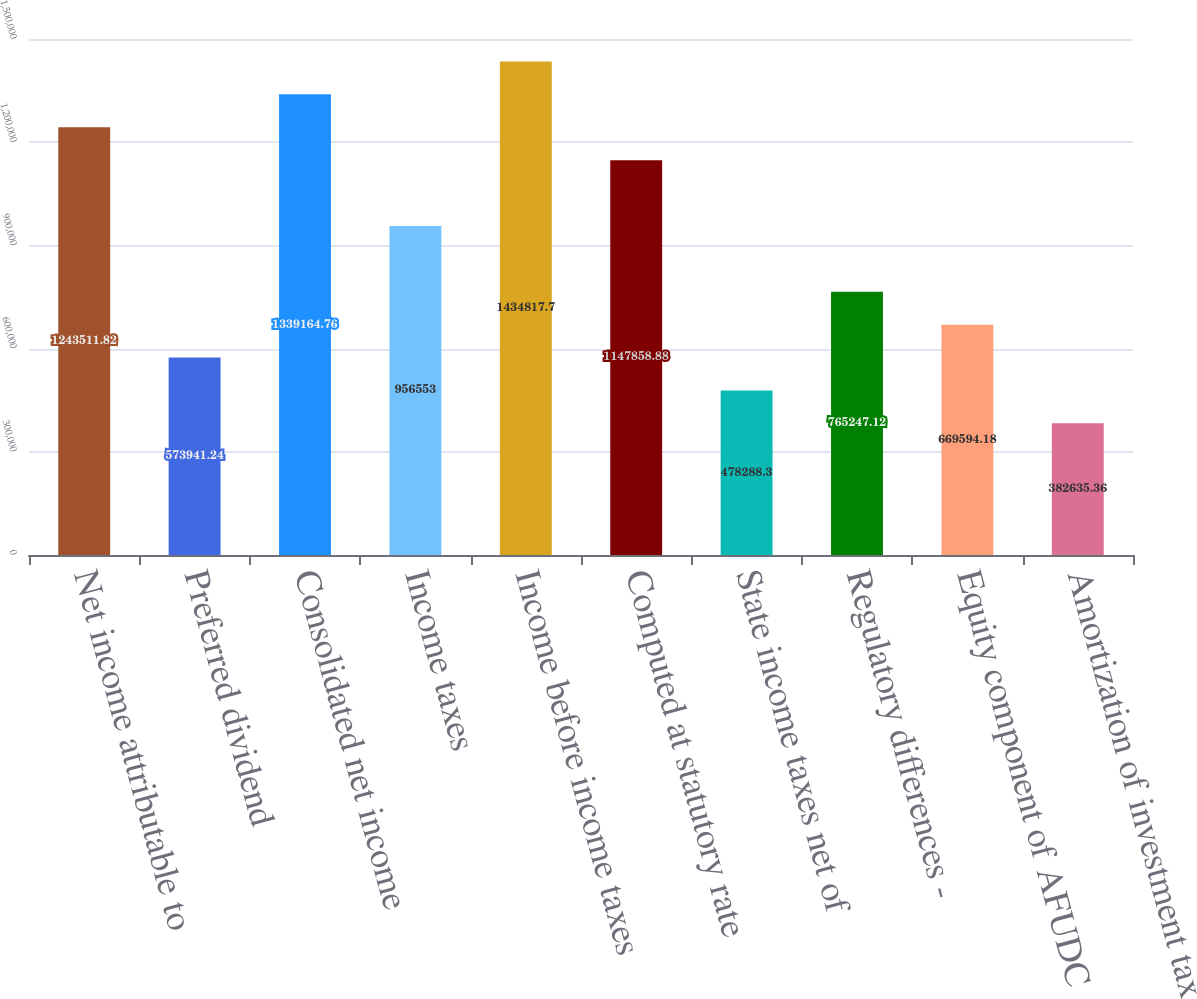Convert chart to OTSL. <chart><loc_0><loc_0><loc_500><loc_500><bar_chart><fcel>Net income attributable to<fcel>Preferred dividend<fcel>Consolidated net income<fcel>Income taxes<fcel>Income before income taxes<fcel>Computed at statutory rate<fcel>State income taxes net of<fcel>Regulatory differences -<fcel>Equity component of AFUDC<fcel>Amortization of investment tax<nl><fcel>1.24351e+06<fcel>573941<fcel>1.33916e+06<fcel>956553<fcel>1.43482e+06<fcel>1.14786e+06<fcel>478288<fcel>765247<fcel>669594<fcel>382635<nl></chart> 